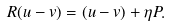<formula> <loc_0><loc_0><loc_500><loc_500>R ( u - v ) = ( u - v ) + \eta P .</formula> 